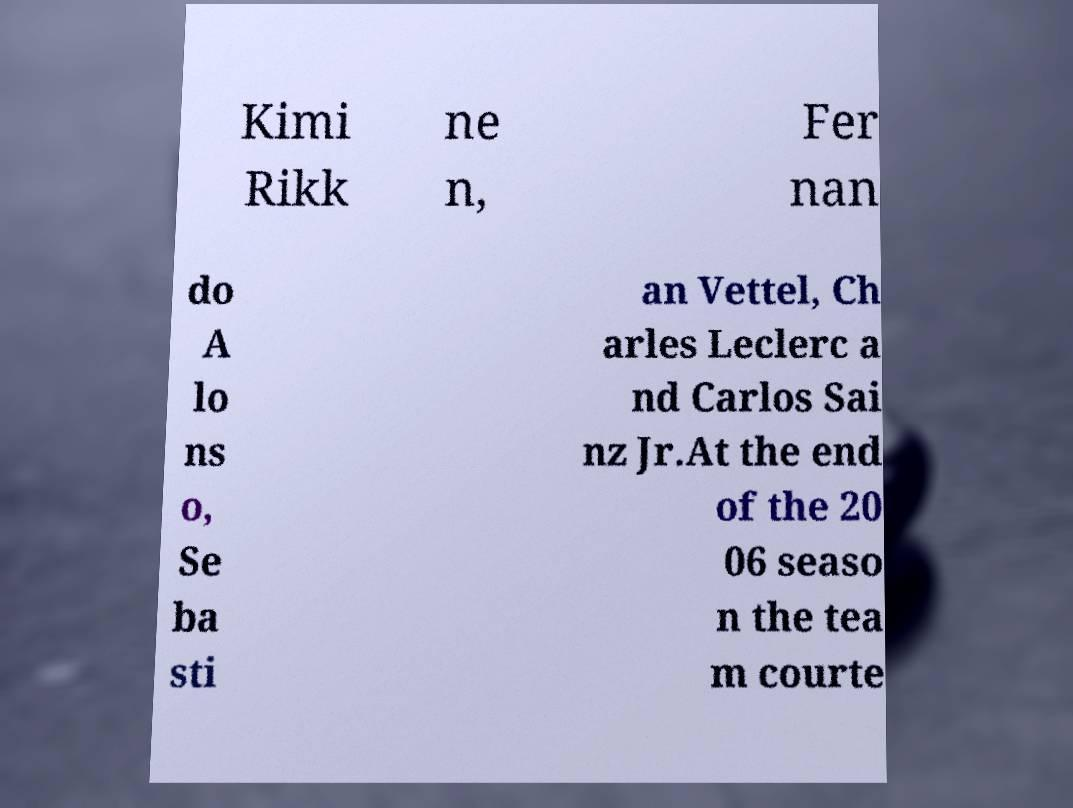Please identify and transcribe the text found in this image. Kimi Rikk ne n, Fer nan do A lo ns o, Se ba sti an Vettel, Ch arles Leclerc a nd Carlos Sai nz Jr.At the end of the 20 06 seaso n the tea m courte 